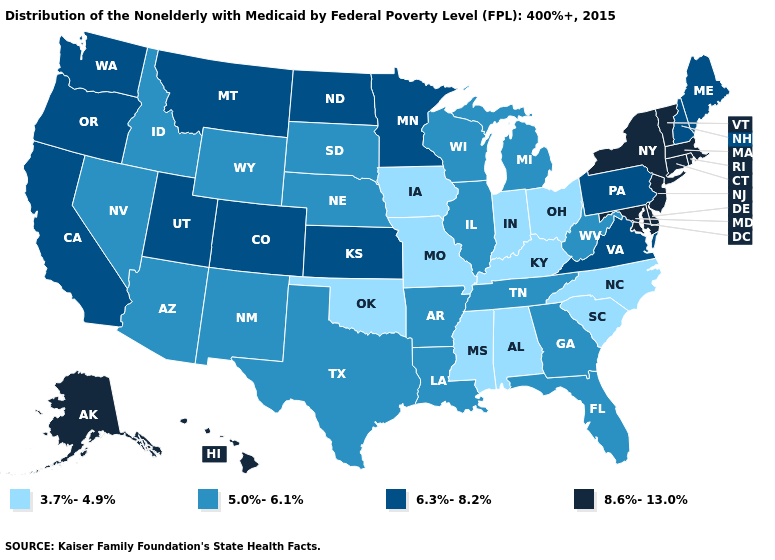What is the value of Georgia?
Quick response, please. 5.0%-6.1%. Name the states that have a value in the range 8.6%-13.0%?
Short answer required. Alaska, Connecticut, Delaware, Hawaii, Maryland, Massachusetts, New Jersey, New York, Rhode Island, Vermont. What is the value of Vermont?
Concise answer only. 8.6%-13.0%. Among the states that border Texas , does Oklahoma have the lowest value?
Be succinct. Yes. What is the value of Georgia?
Quick response, please. 5.0%-6.1%. What is the lowest value in the USA?
Quick response, please. 3.7%-4.9%. Does the map have missing data?
Be succinct. No. Name the states that have a value in the range 8.6%-13.0%?
Be succinct. Alaska, Connecticut, Delaware, Hawaii, Maryland, Massachusetts, New Jersey, New York, Rhode Island, Vermont. What is the value of Pennsylvania?
Quick response, please. 6.3%-8.2%. Name the states that have a value in the range 8.6%-13.0%?
Quick response, please. Alaska, Connecticut, Delaware, Hawaii, Maryland, Massachusetts, New Jersey, New York, Rhode Island, Vermont. What is the lowest value in states that border Rhode Island?
Short answer required. 8.6%-13.0%. What is the highest value in the USA?
Answer briefly. 8.6%-13.0%. Name the states that have a value in the range 5.0%-6.1%?
Quick response, please. Arizona, Arkansas, Florida, Georgia, Idaho, Illinois, Louisiana, Michigan, Nebraska, Nevada, New Mexico, South Dakota, Tennessee, Texas, West Virginia, Wisconsin, Wyoming. Does Indiana have the lowest value in the USA?
Quick response, please. Yes. What is the lowest value in states that border Mississippi?
Concise answer only. 3.7%-4.9%. 